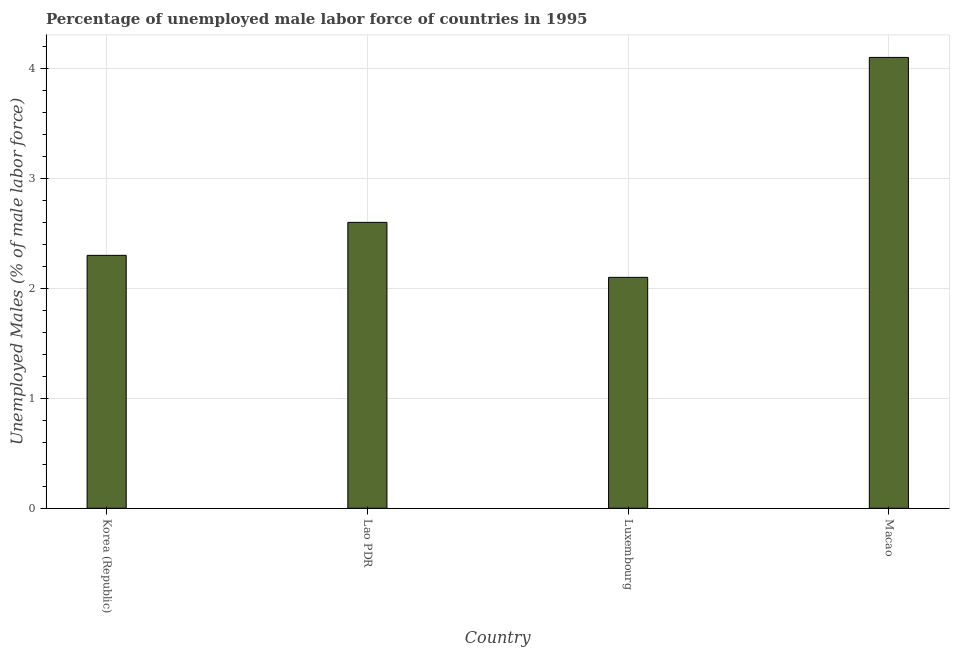Does the graph contain grids?
Make the answer very short. Yes. What is the title of the graph?
Your answer should be very brief. Percentage of unemployed male labor force of countries in 1995. What is the label or title of the X-axis?
Your answer should be very brief. Country. What is the label or title of the Y-axis?
Offer a terse response. Unemployed Males (% of male labor force). What is the total unemployed male labour force in Macao?
Provide a short and direct response. 4.1. Across all countries, what is the maximum total unemployed male labour force?
Make the answer very short. 4.1. Across all countries, what is the minimum total unemployed male labour force?
Provide a short and direct response. 2.1. In which country was the total unemployed male labour force maximum?
Ensure brevity in your answer.  Macao. In which country was the total unemployed male labour force minimum?
Your response must be concise. Luxembourg. What is the sum of the total unemployed male labour force?
Your response must be concise. 11.1. What is the difference between the total unemployed male labour force in Lao PDR and Macao?
Your response must be concise. -1.5. What is the average total unemployed male labour force per country?
Provide a short and direct response. 2.77. What is the median total unemployed male labour force?
Offer a very short reply. 2.45. In how many countries, is the total unemployed male labour force greater than 2.8 %?
Give a very brief answer. 1. What is the ratio of the total unemployed male labour force in Lao PDR to that in Luxembourg?
Offer a terse response. 1.24. Is the total unemployed male labour force in Korea (Republic) less than that in Luxembourg?
Keep it short and to the point. No. Is the difference between the total unemployed male labour force in Korea (Republic) and Luxembourg greater than the difference between any two countries?
Ensure brevity in your answer.  No. What is the difference between the highest and the second highest total unemployed male labour force?
Your answer should be very brief. 1.5. Is the sum of the total unemployed male labour force in Lao PDR and Macao greater than the maximum total unemployed male labour force across all countries?
Provide a succinct answer. Yes. What is the difference between the highest and the lowest total unemployed male labour force?
Provide a short and direct response. 2. In how many countries, is the total unemployed male labour force greater than the average total unemployed male labour force taken over all countries?
Your answer should be compact. 1. How many bars are there?
Provide a succinct answer. 4. What is the difference between two consecutive major ticks on the Y-axis?
Keep it short and to the point. 1. What is the Unemployed Males (% of male labor force) in Korea (Republic)?
Offer a terse response. 2.3. What is the Unemployed Males (% of male labor force) of Lao PDR?
Your answer should be compact. 2.6. What is the Unemployed Males (% of male labor force) in Luxembourg?
Keep it short and to the point. 2.1. What is the Unemployed Males (% of male labor force) in Macao?
Your answer should be very brief. 4.1. What is the difference between the Unemployed Males (% of male labor force) in Korea (Republic) and Lao PDR?
Offer a terse response. -0.3. What is the difference between the Unemployed Males (% of male labor force) in Korea (Republic) and Macao?
Your answer should be compact. -1.8. What is the difference between the Unemployed Males (% of male labor force) in Luxembourg and Macao?
Keep it short and to the point. -2. What is the ratio of the Unemployed Males (% of male labor force) in Korea (Republic) to that in Lao PDR?
Provide a short and direct response. 0.89. What is the ratio of the Unemployed Males (% of male labor force) in Korea (Republic) to that in Luxembourg?
Keep it short and to the point. 1.09. What is the ratio of the Unemployed Males (% of male labor force) in Korea (Republic) to that in Macao?
Provide a short and direct response. 0.56. What is the ratio of the Unemployed Males (% of male labor force) in Lao PDR to that in Luxembourg?
Provide a succinct answer. 1.24. What is the ratio of the Unemployed Males (% of male labor force) in Lao PDR to that in Macao?
Keep it short and to the point. 0.63. What is the ratio of the Unemployed Males (% of male labor force) in Luxembourg to that in Macao?
Give a very brief answer. 0.51. 